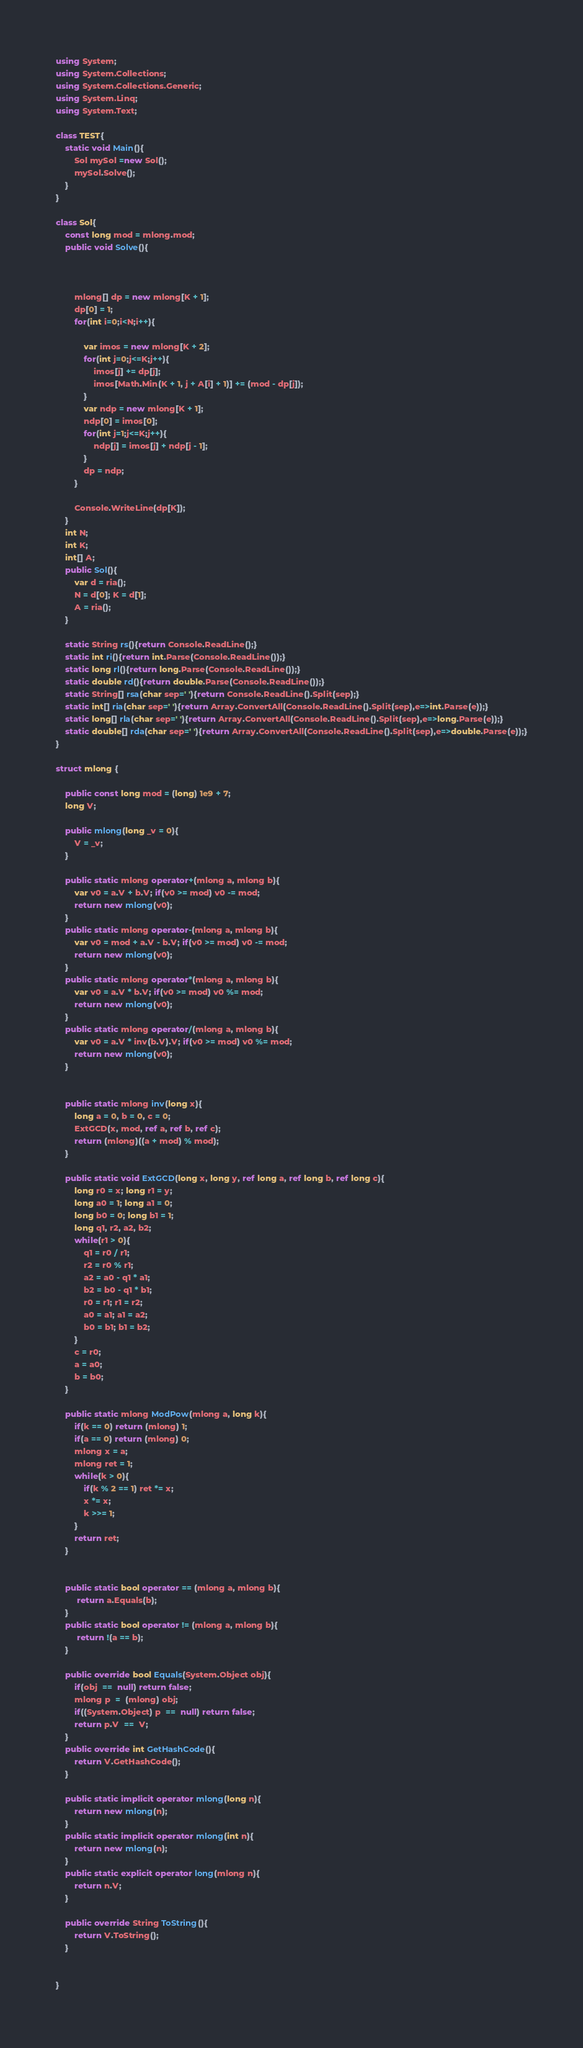Convert code to text. <code><loc_0><loc_0><loc_500><loc_500><_C#_>using System;
using System.Collections;
using System.Collections.Generic;
using System.Linq;
using System.Text;

class TEST{
	static void Main(){
		Sol mySol =new Sol();
		mySol.Solve();
	}
}

class Sol{
	const long mod = mlong.mod;
	public void Solve(){
		
		
		
		mlong[] dp = new mlong[K + 1];
		dp[0] = 1;
		for(int i=0;i<N;i++){
			
			var imos = new mlong[K + 2];
			for(int j=0;j<=K;j++){
				imos[j] += dp[j];
				imos[Math.Min(K + 1, j + A[i] + 1)] += (mod - dp[j]);
			}
			var ndp = new mlong[K + 1];
			ndp[0] = imos[0];
			for(int j=1;j<=K;j++){
				ndp[j] = imos[j] + ndp[j - 1];
			}
			dp = ndp;
		}
		
		Console.WriteLine(dp[K]);
	}
	int N;
	int K;
	int[] A;
	public Sol(){
		var d = ria();
		N = d[0]; K = d[1];
		A = ria();
	}

	static String rs(){return Console.ReadLine();}
	static int ri(){return int.Parse(Console.ReadLine());}
	static long rl(){return long.Parse(Console.ReadLine());}
	static double rd(){return double.Parse(Console.ReadLine());}
	static String[] rsa(char sep=' '){return Console.ReadLine().Split(sep);}
	static int[] ria(char sep=' '){return Array.ConvertAll(Console.ReadLine().Split(sep),e=>int.Parse(e));}
	static long[] rla(char sep=' '){return Array.ConvertAll(Console.ReadLine().Split(sep),e=>long.Parse(e));}
	static double[] rda(char sep=' '){return Array.ConvertAll(Console.ReadLine().Split(sep),e=>double.Parse(e));}
}

struct mlong {
	
	public const long mod = (long) 1e9 + 7;
	long V;
	
	public mlong(long _v = 0){
		V = _v;
	}
	
	public static mlong operator+(mlong a, mlong b){
		var v0 = a.V + b.V; if(v0 >= mod) v0 -= mod;
		return new mlong(v0);
	}
	public static mlong operator-(mlong a, mlong b){
		var v0 = mod + a.V - b.V; if(v0 >= mod) v0 -= mod;
		return new mlong(v0);
	}
	public static mlong operator*(mlong a, mlong b){
		var v0 = a.V * b.V; if(v0 >= mod) v0 %= mod;
		return new mlong(v0);
	}
	public static mlong operator/(mlong a, mlong b){
		var v0 = a.V * inv(b.V).V; if(v0 >= mod) v0 %= mod;
		return new mlong(v0);
	}
	
	
	public static mlong inv(long x){
		long a = 0, b = 0, c = 0;
		ExtGCD(x, mod, ref a, ref b, ref c);
		return (mlong)((a + mod) % mod);
	}
	
	public static void ExtGCD(long x, long y, ref long a, ref long b, ref long c){
		long r0 = x; long r1 = y;
		long a0 = 1; long a1 = 0;
		long b0 = 0; long b1 = 1;
		long q1, r2, a2, b2;
		while(r1 > 0){
			q1 = r0 / r1;
			r2 = r0 % r1;
			a2 = a0 - q1 * a1;
			b2 = b0 - q1 * b1;
			r0 = r1; r1 = r2;
			a0 = a1; a1 = a2;
			b0 = b1; b1 = b2;
		}
		c = r0;
		a = a0;
		b = b0;
	}
	
	public static mlong ModPow(mlong a, long k){
		if(k == 0) return (mlong) 1;
		if(a == 0) return (mlong) 0;
		mlong x = a;
		mlong ret = 1;
		while(k > 0){
			if(k % 2 == 1) ret *= x;
			x *= x;
			k >>= 1;
		}
		return ret;
	}
	
	
	public static bool operator == (mlong a, mlong b){
		 return a.Equals(b);
	}
	public static bool operator != (mlong a, mlong b){
		 return !(a == b);
	}
	
	public override bool Equals(System.Object obj){
		if(obj  ==  null) return false;
		mlong p  =  (mlong) obj;
		if((System.Object) p  ==  null) return false;
		return p.V  ==  V;
	}
	public override int GetHashCode(){
		return V.GetHashCode();
	}
	
	public static implicit operator mlong(long n){
		return new mlong(n);
	}
	public static implicit operator mlong(int n){
		return new mlong(n);
	}
	public static explicit operator long(mlong n){
		return n.V;
	}
	
	public override String ToString(){
		return V.ToString();
	}
	
	
}</code> 